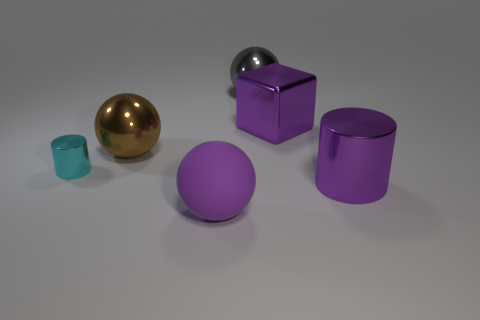Subtract all purple cylinders. Subtract all purple cubes. How many cylinders are left? 1 Add 3 large green shiny things. How many objects exist? 9 Subtract all cubes. How many objects are left? 5 Add 4 big red metallic spheres. How many big red metallic spheres exist? 4 Subtract 0 yellow cylinders. How many objects are left? 6 Subtract all large purple metallic cylinders. Subtract all big purple spheres. How many objects are left? 4 Add 4 cylinders. How many cylinders are left? 6 